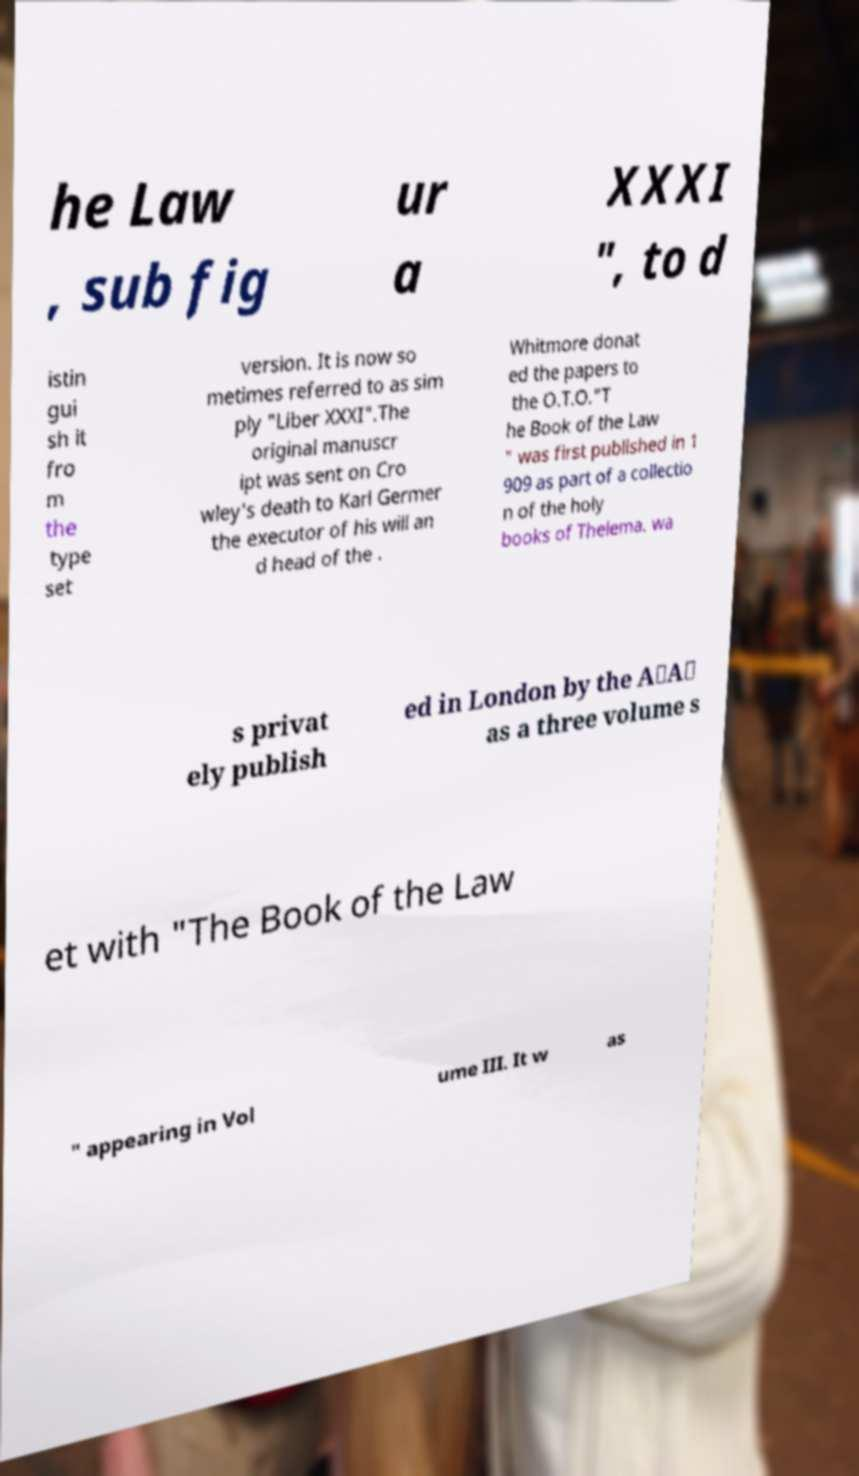There's text embedded in this image that I need extracted. Can you transcribe it verbatim? he Law , sub fig ur a XXXI ", to d istin gui sh it fro m the type set version. It is now so metimes referred to as sim ply "Liber XXXI".The original manuscr ipt was sent on Cro wley's death to Karl Germer the executor of his will an d head of the . Whitmore donat ed the papers to the O.T.O."T he Book of the Law " was first published in 1 909 as part of a collectio n of the holy books of Thelema. wa s privat ely publish ed in London by the A∴A∴ as a three volume s et with "The Book of the Law " appearing in Vol ume III. It w as 